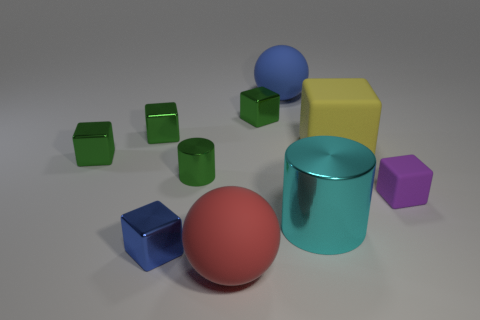What is the shape of the object that is both on the left side of the red rubber thing and in front of the large cyan metal object?
Keep it short and to the point. Cube. Are there any blue metal blocks that have the same size as the purple block?
Offer a terse response. Yes. There is a big metallic cylinder; does it have the same color as the large rubber sphere that is in front of the small blue metallic object?
Provide a short and direct response. No. What is the material of the large yellow object?
Give a very brief answer. Rubber. There is a big rubber ball behind the yellow thing; what color is it?
Offer a very short reply. Blue. What number of big cylinders have the same color as the tiny matte object?
Give a very brief answer. 0. What number of tiny things are to the left of the red rubber sphere and in front of the big yellow matte cube?
Offer a terse response. 3. What is the shape of the yellow matte thing that is the same size as the red rubber ball?
Your response must be concise. Cube. How big is the green shiny cylinder?
Provide a succinct answer. Small. What is the material of the ball behind the matte ball that is in front of the sphere behind the small purple thing?
Your answer should be compact. Rubber. 